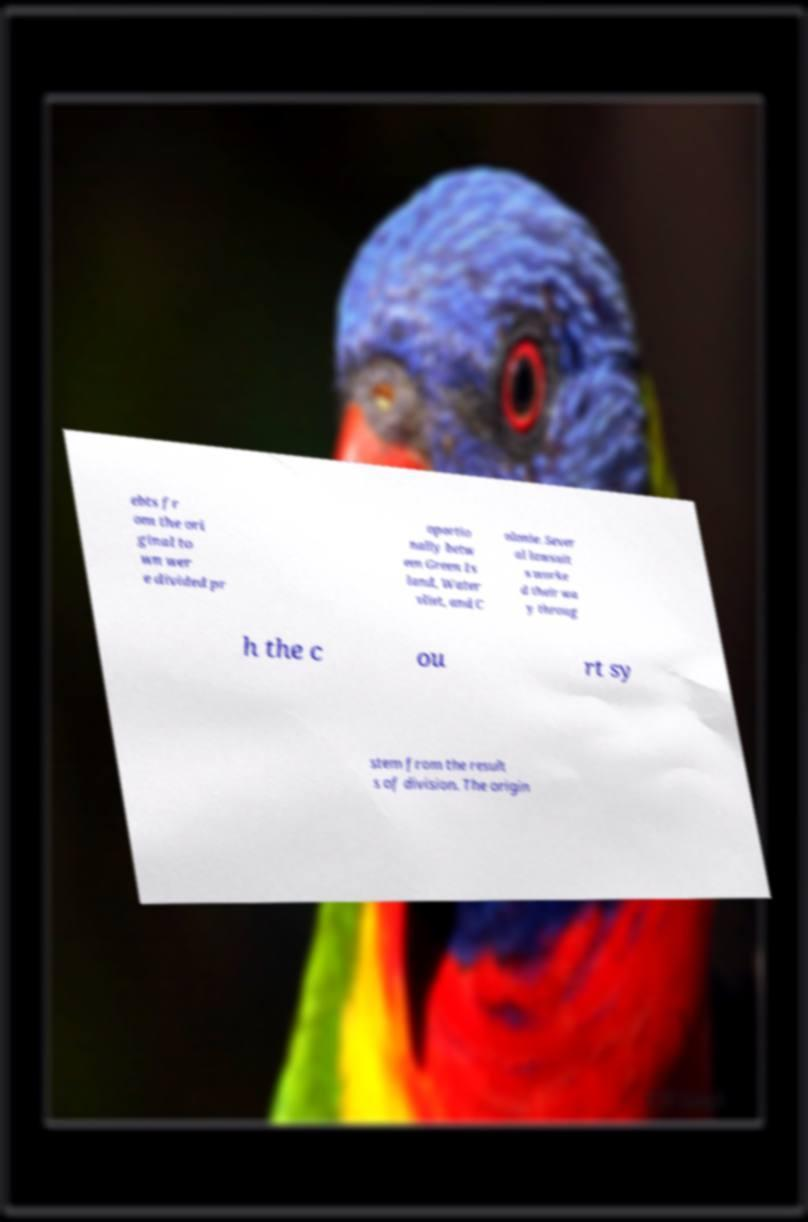Can you read and provide the text displayed in the image?This photo seems to have some interesting text. Can you extract and type it out for me? ebts fr om the ori ginal to wn wer e divided pr oportio nally betw een Green Is land, Water vliet, and C olonie. Sever al lawsuit s worke d their wa y throug h the c ou rt sy stem from the result s of division. The origin 